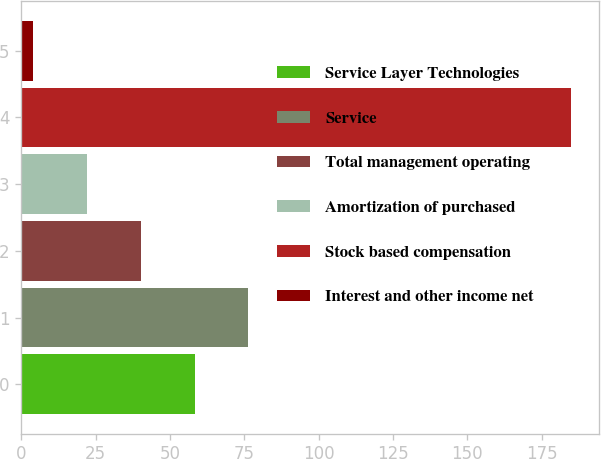<chart> <loc_0><loc_0><loc_500><loc_500><bar_chart><fcel>Service Layer Technologies<fcel>Service<fcel>Total management operating<fcel>Amortization of purchased<fcel>Stock based compensation<fcel>Interest and other income net<nl><fcel>58.3<fcel>76.4<fcel>40.2<fcel>22.1<fcel>185<fcel>4<nl></chart> 